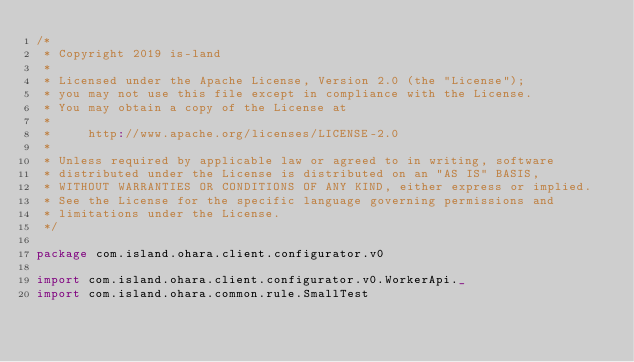<code> <loc_0><loc_0><loc_500><loc_500><_Scala_>/*
 * Copyright 2019 is-land
 *
 * Licensed under the Apache License, Version 2.0 (the "License");
 * you may not use this file except in compliance with the License.
 * You may obtain a copy of the License at
 *
 *     http://www.apache.org/licenses/LICENSE-2.0
 *
 * Unless required by applicable law or agreed to in writing, software
 * distributed under the License is distributed on an "AS IS" BASIS,
 * WITHOUT WARRANTIES OR CONDITIONS OF ANY KIND, either express or implied.
 * See the License for the specific language governing permissions and
 * limitations under the License.
 */

package com.island.ohara.client.configurator.v0

import com.island.ohara.client.configurator.v0.WorkerApi._
import com.island.ohara.common.rule.SmallTest</code> 